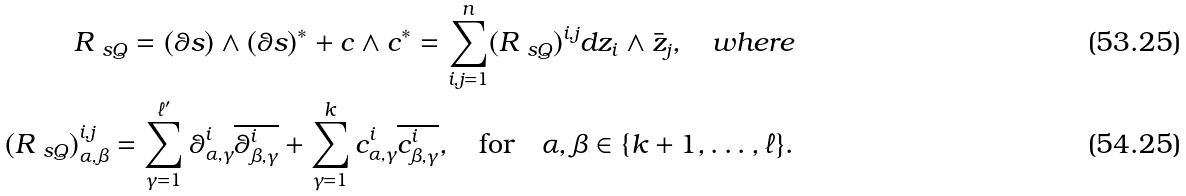Convert formula to latex. <formula><loc_0><loc_0><loc_500><loc_500>R _ { \ s Q } = ( \theta s ) \wedge ( \theta s ) ^ { * } + c \wedge c ^ { * } = \sum _ { i , j = 1 } ^ { n } ( R _ { \ s Q } ) ^ { i , j } d z _ { i } \wedge \bar { z } _ { j } , \quad w h e r e \\ ( R _ { \ s Q } ) ^ { i , j } _ { \alpha , \beta } = \sum _ { \gamma = 1 } ^ { \ell ^ { \prime } } \theta ^ { i } _ { \alpha , \gamma } \overline { \theta ^ { i } _ { \beta , \gamma } } + \sum _ { \gamma = 1 } ^ { k } c ^ { i } _ { \alpha , \gamma } \overline { c ^ { i } _ { \beta , \gamma } } , \quad \text {for} \quad \alpha , \beta \in \{ k + 1 , \dots , \ell \} .</formula> 